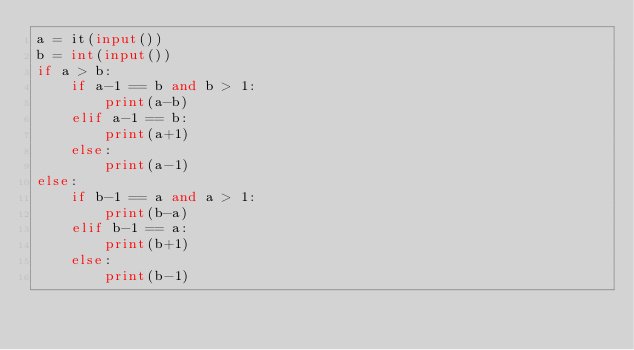<code> <loc_0><loc_0><loc_500><loc_500><_Python_>a = it(input())
b = int(input())
if a > b:
    if a-1 == b and b > 1:
        print(a-b)
    elif a-1 == b:
        print(a+1)
    else:
        print(a-1)
else:
    if b-1 == a and a > 1:
        print(b-a)
    elif b-1 == a:
        print(b+1)
    else:
        print(b-1)

        </code> 